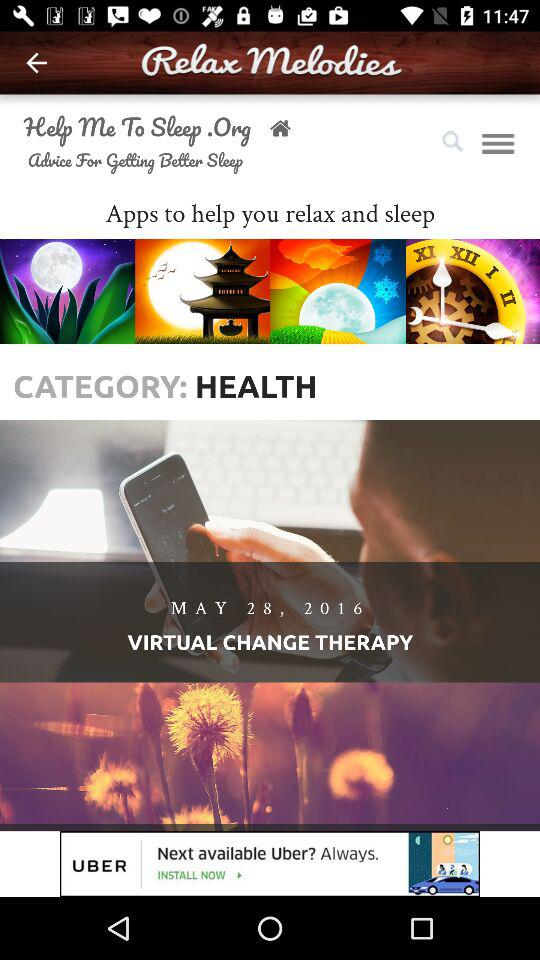What is the date shown on the screen? The shown date is May 28, 2016. 